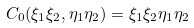Convert formula to latex. <formula><loc_0><loc_0><loc_500><loc_500>C _ { 0 } ( \xi _ { 1 } \xi _ { 2 } , \eta _ { 1 } \eta _ { 2 } ) = \xi _ { 1 } \xi _ { 2 } \eta _ { 1 } \eta _ { 2 }</formula> 